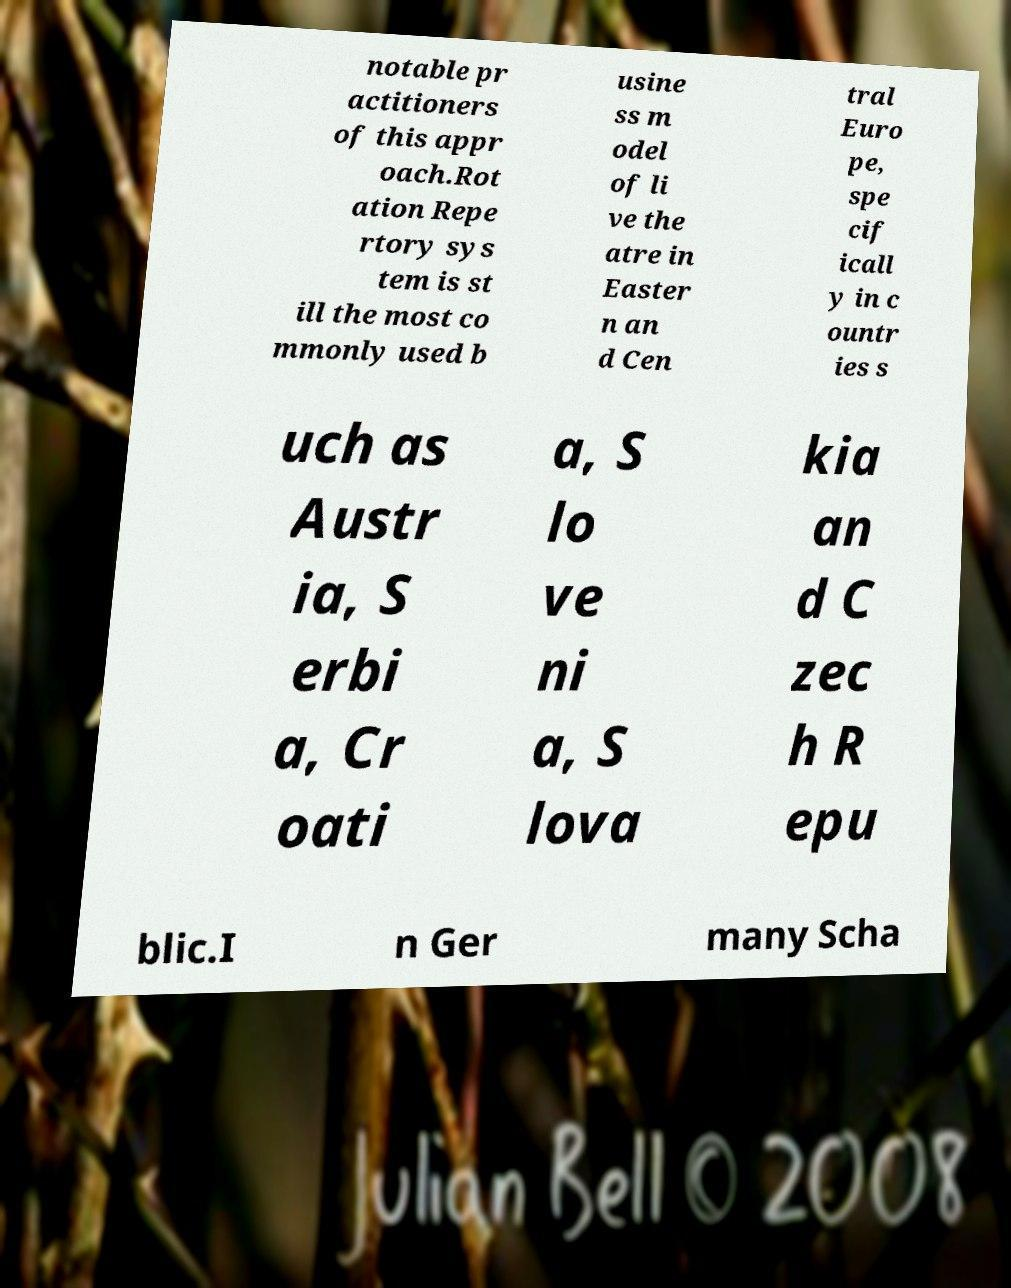I need the written content from this picture converted into text. Can you do that? notable pr actitioners of this appr oach.Rot ation Repe rtory sys tem is st ill the most co mmonly used b usine ss m odel of li ve the atre in Easter n an d Cen tral Euro pe, spe cif icall y in c ountr ies s uch as Austr ia, S erbi a, Cr oati a, S lo ve ni a, S lova kia an d C zec h R epu blic.I n Ger many Scha 